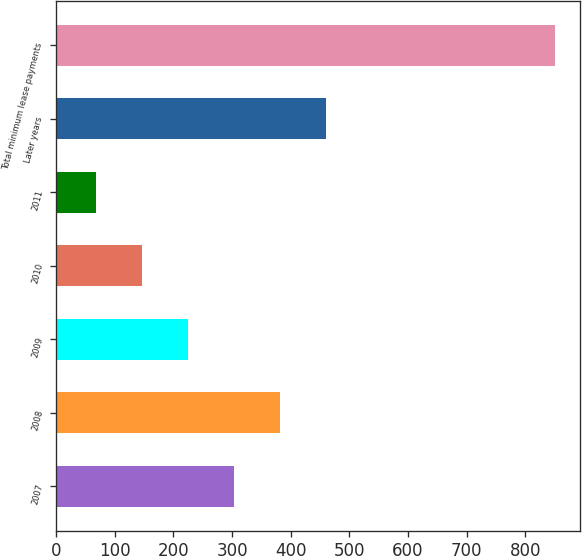<chart> <loc_0><loc_0><loc_500><loc_500><bar_chart><fcel>2007<fcel>2008<fcel>2009<fcel>2010<fcel>2011<fcel>Later years<fcel>Total minimum lease payments<nl><fcel>302.9<fcel>381.2<fcel>224.6<fcel>146.3<fcel>68<fcel>459.5<fcel>851<nl></chart> 